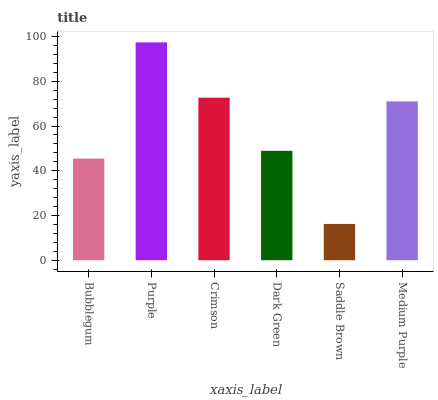Is Crimson the minimum?
Answer yes or no. No. Is Crimson the maximum?
Answer yes or no. No. Is Purple greater than Crimson?
Answer yes or no. Yes. Is Crimson less than Purple?
Answer yes or no. Yes. Is Crimson greater than Purple?
Answer yes or no. No. Is Purple less than Crimson?
Answer yes or no. No. Is Medium Purple the high median?
Answer yes or no. Yes. Is Dark Green the low median?
Answer yes or no. Yes. Is Saddle Brown the high median?
Answer yes or no. No. Is Medium Purple the low median?
Answer yes or no. No. 